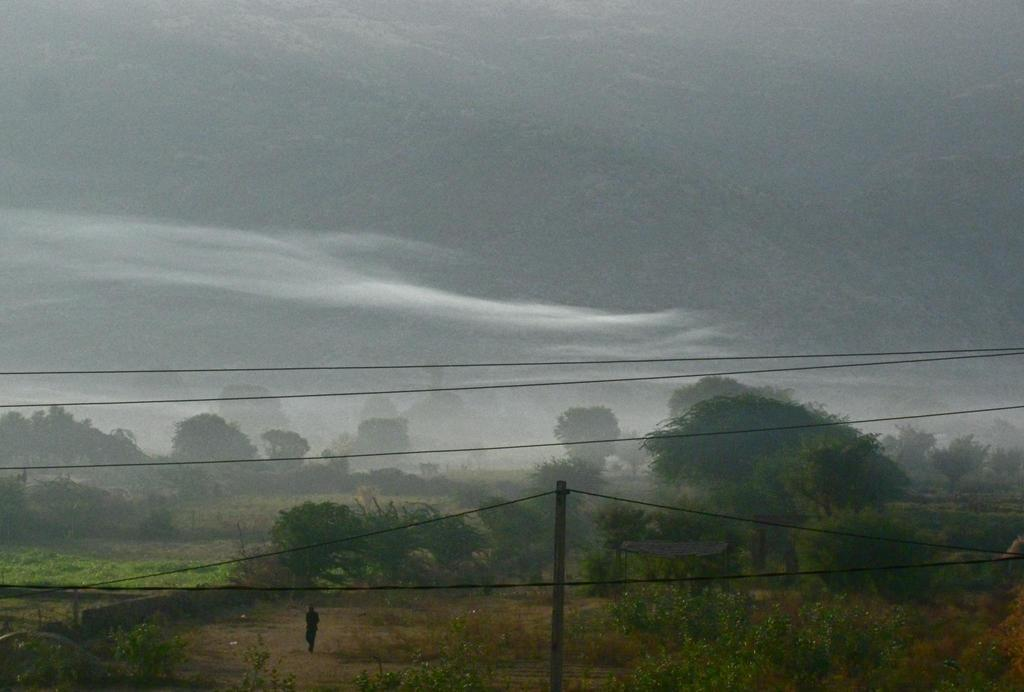What is the main feature of the image? The main feature of the image is the many trees. Can you describe the person in the image? There is a person walking on the ground in the image. What else can be seen in the image besides the trees and person? There is a pole with wires in the image. How would you describe the weather in the image? The sky is cloudy at the top of the image, suggesting a potentially overcast or cloudy day. How many hands are visible in the image? There are no hands visible in the image; it primarily features trees and a person walking. Can you tell me what type of fang is present in the image? There is no fang present in the image. 